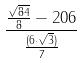Convert formula to latex. <formula><loc_0><loc_0><loc_500><loc_500>\frac { \frac { \sqrt { 8 4 } } { 8 } - 2 0 6 } { \frac { ( 6 \cdot \sqrt { 3 } ) } { 7 } }</formula> 